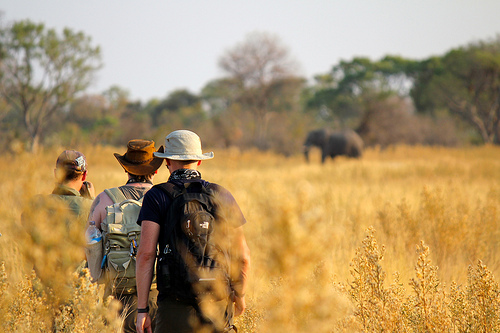If you were to imagine a conversation between the men about their journey, what might they say? Man 1: 'Look at that elephant in the distance. It's magnificent. I feel lucky to witness this firsthand.'
Man 2: 'Absolutely, it's moments like these that make the journey worthwhile. Have we logged our observations for today?'
Man 3: 'Yes, I noted the coordinates and the approximate distance. We might be able to get a little closer without disturbing it. Also, should we set up camp here for the night? The sun will be setting soon.'
Man 1: 'Good idea. Let's find a spot with some cover but still within view of the elephants. It’s crucial to keep our presence as unobtrusive as possible while we gather data.'
Man 2: 'And keep an eye on the weather. There was mention of a potential storm later today; we need to be prepared for anything.' 